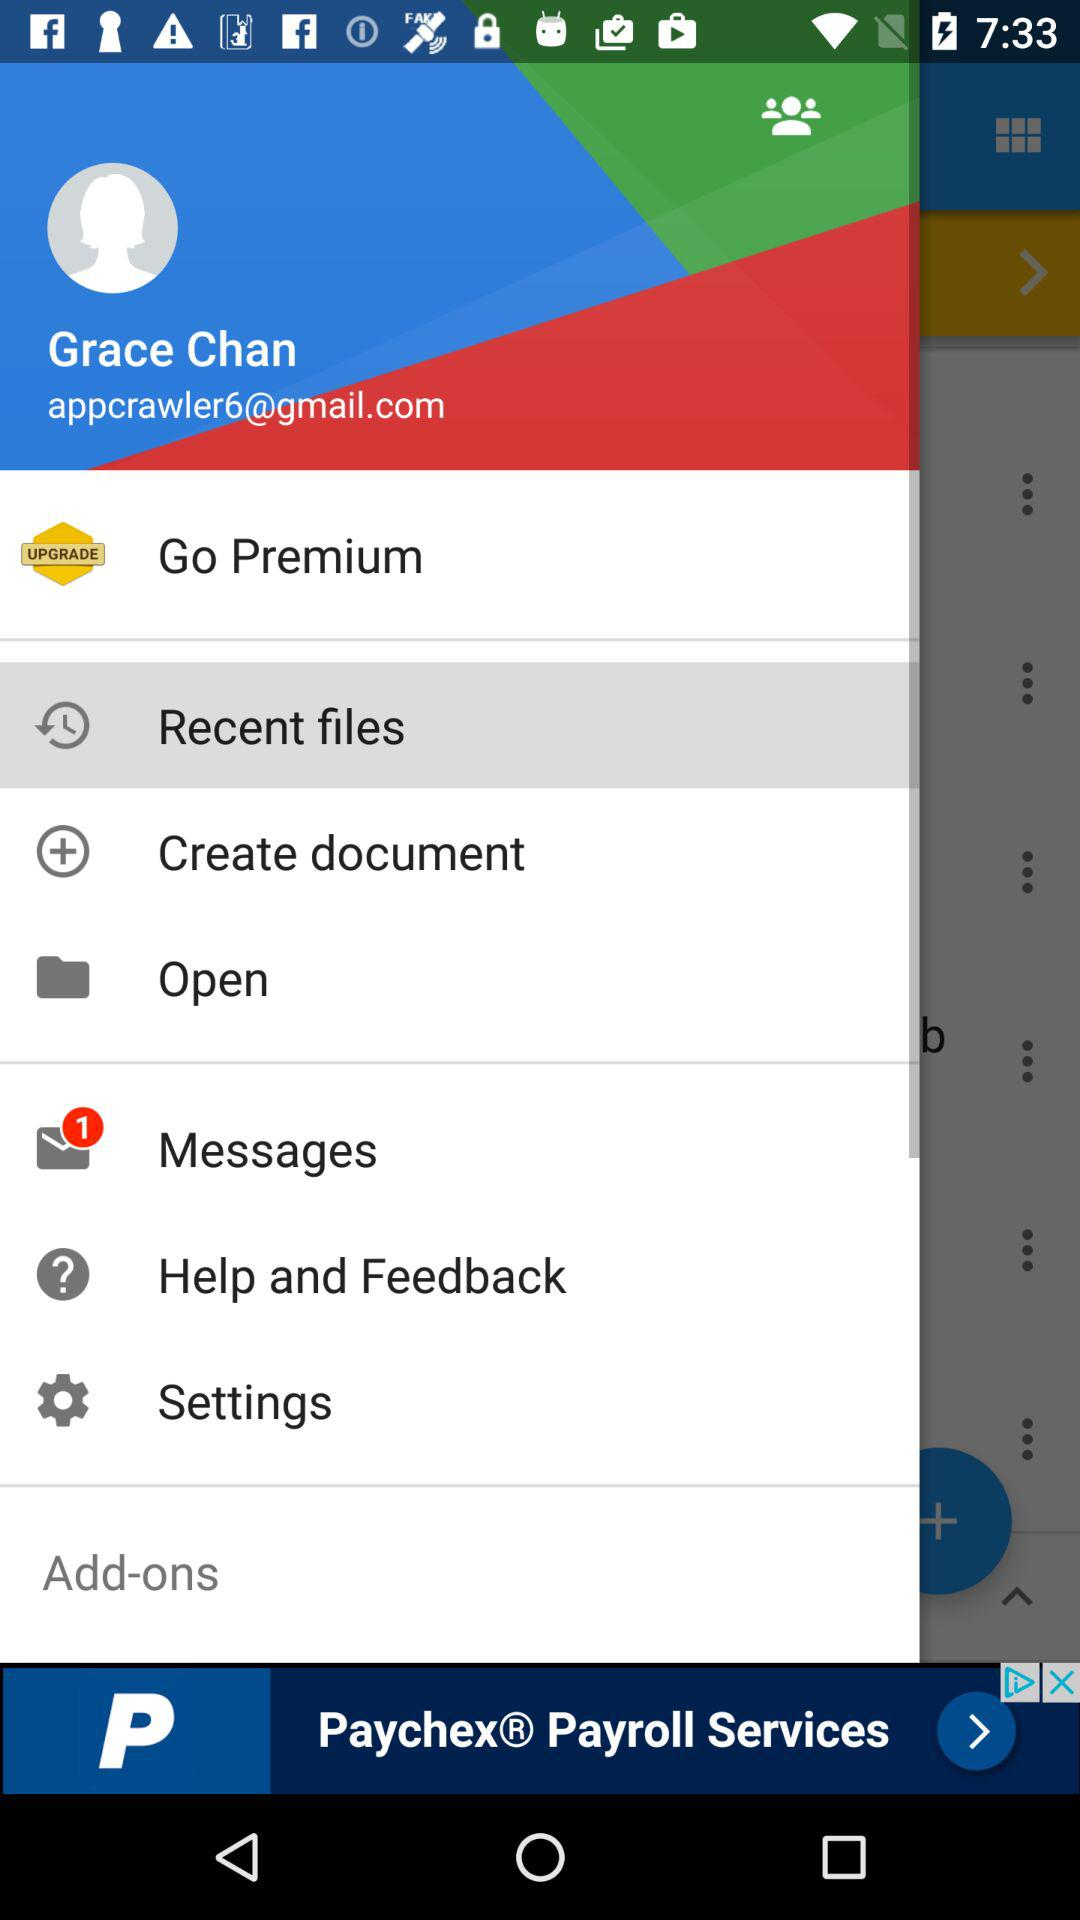Which is the selected item in the menu? The selected item in the menu is "Recent files". 